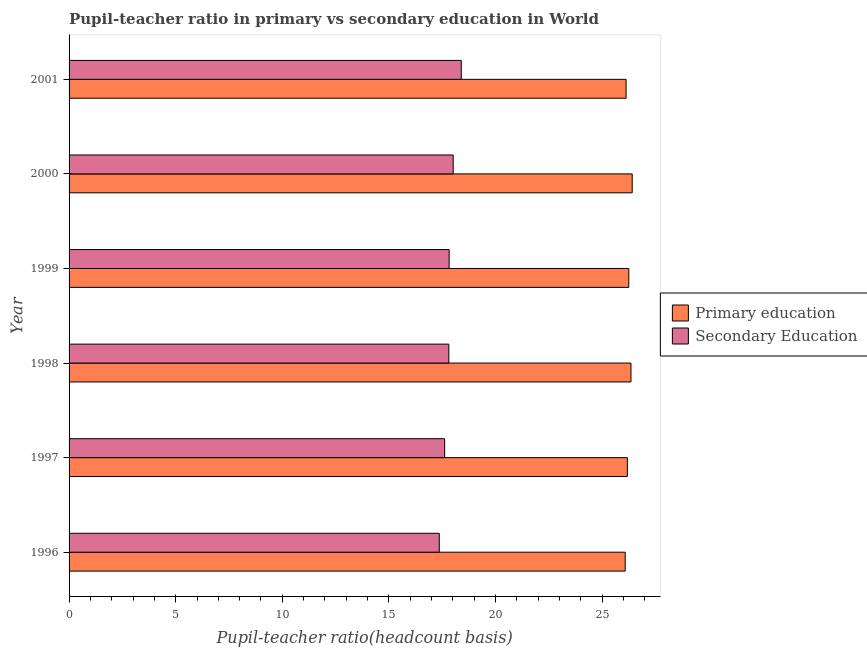How many different coloured bars are there?
Provide a short and direct response. 2. Are the number of bars on each tick of the Y-axis equal?
Your answer should be compact. Yes. How many bars are there on the 1st tick from the top?
Keep it short and to the point. 2. What is the label of the 2nd group of bars from the top?
Provide a succinct answer. 2000. In how many cases, is the number of bars for a given year not equal to the number of legend labels?
Your answer should be compact. 0. What is the pupil teacher ratio on secondary education in 1996?
Provide a succinct answer. 17.36. Across all years, what is the maximum pupil-teacher ratio in primary education?
Your answer should be compact. 26.41. Across all years, what is the minimum pupil teacher ratio on secondary education?
Provide a succinct answer. 17.36. What is the total pupil teacher ratio on secondary education in the graph?
Your answer should be compact. 107.02. What is the difference between the pupil teacher ratio on secondary education in 2000 and that in 2001?
Make the answer very short. -0.38. What is the difference between the pupil teacher ratio on secondary education in 1997 and the pupil-teacher ratio in primary education in 2000?
Your answer should be compact. -8.8. What is the average pupil-teacher ratio in primary education per year?
Ensure brevity in your answer.  26.23. In the year 1997, what is the difference between the pupil teacher ratio on secondary education and pupil-teacher ratio in primary education?
Your answer should be compact. -8.57. What is the ratio of the pupil teacher ratio on secondary education in 1999 to that in 2000?
Your response must be concise. 0.99. Is the pupil teacher ratio on secondary education in 1998 less than that in 1999?
Provide a succinct answer. Yes. What is the difference between the highest and the second highest pupil teacher ratio on secondary education?
Offer a terse response. 0.38. What is the difference between the highest and the lowest pupil teacher ratio on secondary education?
Ensure brevity in your answer.  1.03. Is the sum of the pupil-teacher ratio in primary education in 1997 and 2001 greater than the maximum pupil teacher ratio on secondary education across all years?
Keep it short and to the point. Yes. What does the 1st bar from the top in 2000 represents?
Your response must be concise. Secondary Education. What does the 2nd bar from the bottom in 1997 represents?
Provide a short and direct response. Secondary Education. How many bars are there?
Provide a succinct answer. 12. Are all the bars in the graph horizontal?
Offer a very short reply. Yes. How many years are there in the graph?
Offer a very short reply. 6. What is the difference between two consecutive major ticks on the X-axis?
Your response must be concise. 5. Are the values on the major ticks of X-axis written in scientific E-notation?
Offer a terse response. No. Does the graph contain grids?
Your answer should be very brief. No. How many legend labels are there?
Your answer should be compact. 2. How are the legend labels stacked?
Offer a terse response. Vertical. What is the title of the graph?
Your answer should be compact. Pupil-teacher ratio in primary vs secondary education in World. Does "Borrowers" appear as one of the legend labels in the graph?
Keep it short and to the point. No. What is the label or title of the X-axis?
Your answer should be very brief. Pupil-teacher ratio(headcount basis). What is the label or title of the Y-axis?
Make the answer very short. Year. What is the Pupil-teacher ratio(headcount basis) of Primary education in 1996?
Provide a short and direct response. 26.08. What is the Pupil-teacher ratio(headcount basis) of Secondary Education in 1996?
Make the answer very short. 17.36. What is the Pupil-teacher ratio(headcount basis) of Primary education in 1997?
Offer a very short reply. 26.18. What is the Pupil-teacher ratio(headcount basis) of Secondary Education in 1997?
Give a very brief answer. 17.61. What is the Pupil-teacher ratio(headcount basis) in Primary education in 1998?
Provide a short and direct response. 26.35. What is the Pupil-teacher ratio(headcount basis) in Secondary Education in 1998?
Provide a short and direct response. 17.81. What is the Pupil-teacher ratio(headcount basis) of Primary education in 1999?
Ensure brevity in your answer.  26.25. What is the Pupil-teacher ratio(headcount basis) in Secondary Education in 1999?
Offer a very short reply. 17.82. What is the Pupil-teacher ratio(headcount basis) of Primary education in 2000?
Provide a succinct answer. 26.41. What is the Pupil-teacher ratio(headcount basis) of Secondary Education in 2000?
Give a very brief answer. 18.01. What is the Pupil-teacher ratio(headcount basis) of Primary education in 2001?
Provide a short and direct response. 26.12. What is the Pupil-teacher ratio(headcount basis) in Secondary Education in 2001?
Keep it short and to the point. 18.39. Across all years, what is the maximum Pupil-teacher ratio(headcount basis) of Primary education?
Your answer should be very brief. 26.41. Across all years, what is the maximum Pupil-teacher ratio(headcount basis) in Secondary Education?
Provide a succinct answer. 18.39. Across all years, what is the minimum Pupil-teacher ratio(headcount basis) in Primary education?
Provide a short and direct response. 26.08. Across all years, what is the minimum Pupil-teacher ratio(headcount basis) of Secondary Education?
Offer a very short reply. 17.36. What is the total Pupil-teacher ratio(headcount basis) of Primary education in the graph?
Offer a terse response. 157.39. What is the total Pupil-teacher ratio(headcount basis) in Secondary Education in the graph?
Your answer should be compact. 107.02. What is the difference between the Pupil-teacher ratio(headcount basis) in Primary education in 1996 and that in 1997?
Your response must be concise. -0.1. What is the difference between the Pupil-teacher ratio(headcount basis) of Secondary Education in 1996 and that in 1997?
Provide a succinct answer. -0.25. What is the difference between the Pupil-teacher ratio(headcount basis) in Primary education in 1996 and that in 1998?
Your answer should be compact. -0.27. What is the difference between the Pupil-teacher ratio(headcount basis) in Secondary Education in 1996 and that in 1998?
Ensure brevity in your answer.  -0.45. What is the difference between the Pupil-teacher ratio(headcount basis) in Primary education in 1996 and that in 1999?
Your answer should be very brief. -0.17. What is the difference between the Pupil-teacher ratio(headcount basis) in Secondary Education in 1996 and that in 1999?
Ensure brevity in your answer.  -0.46. What is the difference between the Pupil-teacher ratio(headcount basis) of Primary education in 1996 and that in 2000?
Make the answer very short. -0.33. What is the difference between the Pupil-teacher ratio(headcount basis) of Secondary Education in 1996 and that in 2000?
Provide a short and direct response. -0.65. What is the difference between the Pupil-teacher ratio(headcount basis) of Primary education in 1996 and that in 2001?
Your response must be concise. -0.04. What is the difference between the Pupil-teacher ratio(headcount basis) of Secondary Education in 1996 and that in 2001?
Offer a very short reply. -1.03. What is the difference between the Pupil-teacher ratio(headcount basis) of Primary education in 1997 and that in 1998?
Give a very brief answer. -0.17. What is the difference between the Pupil-teacher ratio(headcount basis) in Secondary Education in 1997 and that in 1998?
Keep it short and to the point. -0.2. What is the difference between the Pupil-teacher ratio(headcount basis) of Primary education in 1997 and that in 1999?
Give a very brief answer. -0.07. What is the difference between the Pupil-teacher ratio(headcount basis) of Secondary Education in 1997 and that in 1999?
Make the answer very short. -0.21. What is the difference between the Pupil-teacher ratio(headcount basis) of Primary education in 1997 and that in 2000?
Provide a succinct answer. -0.23. What is the difference between the Pupil-teacher ratio(headcount basis) in Secondary Education in 1997 and that in 2000?
Ensure brevity in your answer.  -0.4. What is the difference between the Pupil-teacher ratio(headcount basis) of Primary education in 1997 and that in 2001?
Make the answer very short. 0.06. What is the difference between the Pupil-teacher ratio(headcount basis) of Secondary Education in 1997 and that in 2001?
Keep it short and to the point. -0.78. What is the difference between the Pupil-teacher ratio(headcount basis) in Primary education in 1998 and that in 1999?
Provide a succinct answer. 0.1. What is the difference between the Pupil-teacher ratio(headcount basis) in Secondary Education in 1998 and that in 1999?
Ensure brevity in your answer.  -0.01. What is the difference between the Pupil-teacher ratio(headcount basis) of Primary education in 1998 and that in 2000?
Offer a terse response. -0.06. What is the difference between the Pupil-teacher ratio(headcount basis) of Secondary Education in 1998 and that in 2000?
Ensure brevity in your answer.  -0.2. What is the difference between the Pupil-teacher ratio(headcount basis) in Primary education in 1998 and that in 2001?
Your answer should be compact. 0.23. What is the difference between the Pupil-teacher ratio(headcount basis) of Secondary Education in 1998 and that in 2001?
Give a very brief answer. -0.58. What is the difference between the Pupil-teacher ratio(headcount basis) in Primary education in 1999 and that in 2000?
Give a very brief answer. -0.16. What is the difference between the Pupil-teacher ratio(headcount basis) of Secondary Education in 1999 and that in 2000?
Keep it short and to the point. -0.19. What is the difference between the Pupil-teacher ratio(headcount basis) of Primary education in 1999 and that in 2001?
Your answer should be compact. 0.13. What is the difference between the Pupil-teacher ratio(headcount basis) of Secondary Education in 1999 and that in 2001?
Keep it short and to the point. -0.57. What is the difference between the Pupil-teacher ratio(headcount basis) of Primary education in 2000 and that in 2001?
Provide a succinct answer. 0.29. What is the difference between the Pupil-teacher ratio(headcount basis) of Secondary Education in 2000 and that in 2001?
Provide a succinct answer. -0.38. What is the difference between the Pupil-teacher ratio(headcount basis) in Primary education in 1996 and the Pupil-teacher ratio(headcount basis) in Secondary Education in 1997?
Your response must be concise. 8.47. What is the difference between the Pupil-teacher ratio(headcount basis) in Primary education in 1996 and the Pupil-teacher ratio(headcount basis) in Secondary Education in 1998?
Your response must be concise. 8.27. What is the difference between the Pupil-teacher ratio(headcount basis) of Primary education in 1996 and the Pupil-teacher ratio(headcount basis) of Secondary Education in 1999?
Ensure brevity in your answer.  8.26. What is the difference between the Pupil-teacher ratio(headcount basis) in Primary education in 1996 and the Pupil-teacher ratio(headcount basis) in Secondary Education in 2000?
Offer a very short reply. 8.07. What is the difference between the Pupil-teacher ratio(headcount basis) in Primary education in 1996 and the Pupil-teacher ratio(headcount basis) in Secondary Education in 2001?
Provide a short and direct response. 7.69. What is the difference between the Pupil-teacher ratio(headcount basis) in Primary education in 1997 and the Pupil-teacher ratio(headcount basis) in Secondary Education in 1998?
Your answer should be compact. 8.37. What is the difference between the Pupil-teacher ratio(headcount basis) of Primary education in 1997 and the Pupil-teacher ratio(headcount basis) of Secondary Education in 1999?
Keep it short and to the point. 8.36. What is the difference between the Pupil-teacher ratio(headcount basis) of Primary education in 1997 and the Pupil-teacher ratio(headcount basis) of Secondary Education in 2000?
Your response must be concise. 8.17. What is the difference between the Pupil-teacher ratio(headcount basis) in Primary education in 1997 and the Pupil-teacher ratio(headcount basis) in Secondary Education in 2001?
Provide a short and direct response. 7.79. What is the difference between the Pupil-teacher ratio(headcount basis) of Primary education in 1998 and the Pupil-teacher ratio(headcount basis) of Secondary Education in 1999?
Offer a very short reply. 8.53. What is the difference between the Pupil-teacher ratio(headcount basis) in Primary education in 1998 and the Pupil-teacher ratio(headcount basis) in Secondary Education in 2000?
Your answer should be very brief. 8.34. What is the difference between the Pupil-teacher ratio(headcount basis) of Primary education in 1998 and the Pupil-teacher ratio(headcount basis) of Secondary Education in 2001?
Your answer should be very brief. 7.96. What is the difference between the Pupil-teacher ratio(headcount basis) in Primary education in 1999 and the Pupil-teacher ratio(headcount basis) in Secondary Education in 2000?
Keep it short and to the point. 8.24. What is the difference between the Pupil-teacher ratio(headcount basis) in Primary education in 1999 and the Pupil-teacher ratio(headcount basis) in Secondary Education in 2001?
Provide a succinct answer. 7.86. What is the difference between the Pupil-teacher ratio(headcount basis) of Primary education in 2000 and the Pupil-teacher ratio(headcount basis) of Secondary Education in 2001?
Offer a terse response. 8.02. What is the average Pupil-teacher ratio(headcount basis) in Primary education per year?
Offer a terse response. 26.23. What is the average Pupil-teacher ratio(headcount basis) of Secondary Education per year?
Offer a terse response. 17.84. In the year 1996, what is the difference between the Pupil-teacher ratio(headcount basis) in Primary education and Pupil-teacher ratio(headcount basis) in Secondary Education?
Offer a very short reply. 8.72. In the year 1997, what is the difference between the Pupil-teacher ratio(headcount basis) in Primary education and Pupil-teacher ratio(headcount basis) in Secondary Education?
Provide a short and direct response. 8.57. In the year 1998, what is the difference between the Pupil-teacher ratio(headcount basis) of Primary education and Pupil-teacher ratio(headcount basis) of Secondary Education?
Ensure brevity in your answer.  8.54. In the year 1999, what is the difference between the Pupil-teacher ratio(headcount basis) of Primary education and Pupil-teacher ratio(headcount basis) of Secondary Education?
Your answer should be very brief. 8.42. In the year 2000, what is the difference between the Pupil-teacher ratio(headcount basis) in Primary education and Pupil-teacher ratio(headcount basis) in Secondary Education?
Make the answer very short. 8.39. In the year 2001, what is the difference between the Pupil-teacher ratio(headcount basis) of Primary education and Pupil-teacher ratio(headcount basis) of Secondary Education?
Offer a terse response. 7.73. What is the ratio of the Pupil-teacher ratio(headcount basis) in Secondary Education in 1996 to that in 1997?
Ensure brevity in your answer.  0.99. What is the ratio of the Pupil-teacher ratio(headcount basis) of Secondary Education in 1996 to that in 1998?
Your response must be concise. 0.97. What is the ratio of the Pupil-teacher ratio(headcount basis) in Secondary Education in 1996 to that in 1999?
Give a very brief answer. 0.97. What is the ratio of the Pupil-teacher ratio(headcount basis) of Primary education in 1996 to that in 2000?
Give a very brief answer. 0.99. What is the ratio of the Pupil-teacher ratio(headcount basis) in Secondary Education in 1996 to that in 2000?
Make the answer very short. 0.96. What is the ratio of the Pupil-teacher ratio(headcount basis) of Secondary Education in 1996 to that in 2001?
Your answer should be compact. 0.94. What is the ratio of the Pupil-teacher ratio(headcount basis) of Secondary Education in 1997 to that in 1998?
Make the answer very short. 0.99. What is the ratio of the Pupil-teacher ratio(headcount basis) of Primary education in 1997 to that in 1999?
Offer a terse response. 1. What is the ratio of the Pupil-teacher ratio(headcount basis) of Secondary Education in 1997 to that in 1999?
Ensure brevity in your answer.  0.99. What is the ratio of the Pupil-teacher ratio(headcount basis) of Secondary Education in 1997 to that in 2000?
Provide a succinct answer. 0.98. What is the ratio of the Pupil-teacher ratio(headcount basis) in Secondary Education in 1997 to that in 2001?
Provide a succinct answer. 0.96. What is the ratio of the Pupil-teacher ratio(headcount basis) of Secondary Education in 1998 to that in 2000?
Make the answer very short. 0.99. What is the ratio of the Pupil-teacher ratio(headcount basis) in Primary education in 1998 to that in 2001?
Provide a succinct answer. 1.01. What is the ratio of the Pupil-teacher ratio(headcount basis) of Secondary Education in 1998 to that in 2001?
Keep it short and to the point. 0.97. What is the ratio of the Pupil-teacher ratio(headcount basis) of Primary education in 1999 to that in 2000?
Provide a succinct answer. 0.99. What is the ratio of the Pupil-teacher ratio(headcount basis) in Primary education in 1999 to that in 2001?
Your answer should be very brief. 1. What is the ratio of the Pupil-teacher ratio(headcount basis) of Secondary Education in 1999 to that in 2001?
Ensure brevity in your answer.  0.97. What is the ratio of the Pupil-teacher ratio(headcount basis) in Primary education in 2000 to that in 2001?
Provide a succinct answer. 1.01. What is the ratio of the Pupil-teacher ratio(headcount basis) of Secondary Education in 2000 to that in 2001?
Your answer should be very brief. 0.98. What is the difference between the highest and the second highest Pupil-teacher ratio(headcount basis) of Primary education?
Your response must be concise. 0.06. What is the difference between the highest and the second highest Pupil-teacher ratio(headcount basis) in Secondary Education?
Ensure brevity in your answer.  0.38. What is the difference between the highest and the lowest Pupil-teacher ratio(headcount basis) in Primary education?
Keep it short and to the point. 0.33. What is the difference between the highest and the lowest Pupil-teacher ratio(headcount basis) in Secondary Education?
Provide a succinct answer. 1.03. 